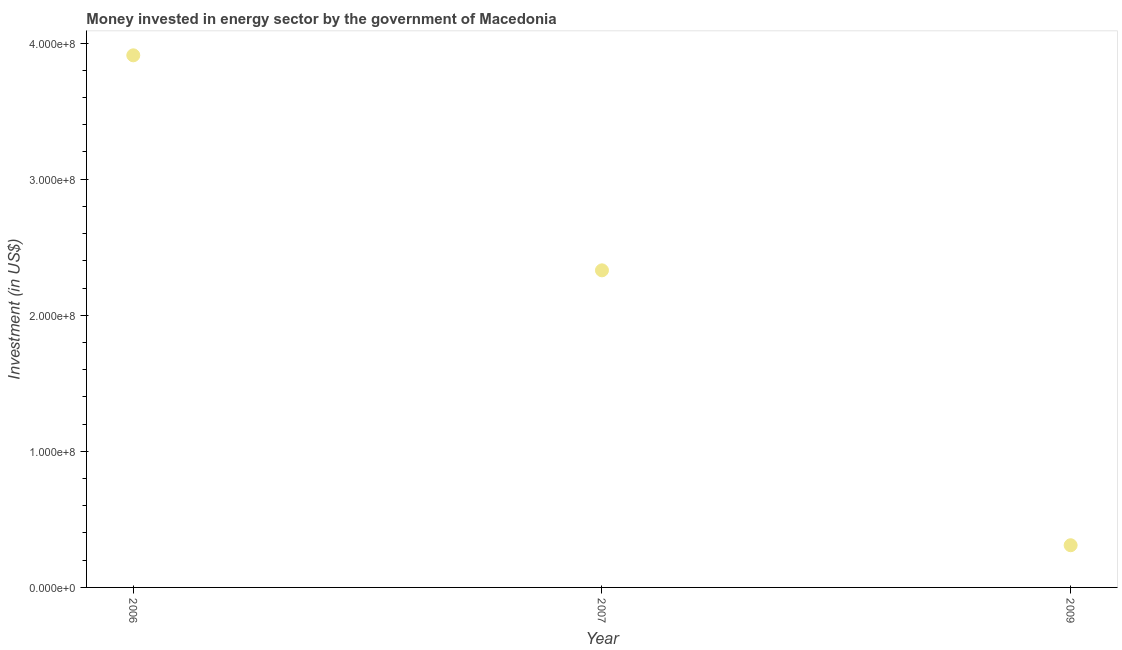What is the investment in energy in 2009?
Give a very brief answer. 3.10e+07. Across all years, what is the maximum investment in energy?
Your response must be concise. 3.91e+08. Across all years, what is the minimum investment in energy?
Provide a succinct answer. 3.10e+07. In which year was the investment in energy maximum?
Your answer should be compact. 2006. In which year was the investment in energy minimum?
Keep it short and to the point. 2009. What is the sum of the investment in energy?
Provide a succinct answer. 6.55e+08. What is the difference between the investment in energy in 2007 and 2009?
Your answer should be very brief. 2.02e+08. What is the average investment in energy per year?
Your answer should be compact. 2.18e+08. What is the median investment in energy?
Provide a succinct answer. 2.33e+08. Do a majority of the years between 2006 and 2007 (inclusive) have investment in energy greater than 140000000 US$?
Make the answer very short. Yes. What is the ratio of the investment in energy in 2006 to that in 2009?
Offer a terse response. 12.61. Is the difference between the investment in energy in 2007 and 2009 greater than the difference between any two years?
Your response must be concise. No. What is the difference between the highest and the second highest investment in energy?
Offer a very short reply. 1.58e+08. What is the difference between the highest and the lowest investment in energy?
Offer a very short reply. 3.60e+08. In how many years, is the investment in energy greater than the average investment in energy taken over all years?
Offer a very short reply. 2. What is the difference between two consecutive major ticks on the Y-axis?
Keep it short and to the point. 1.00e+08. Are the values on the major ticks of Y-axis written in scientific E-notation?
Offer a terse response. Yes. Does the graph contain any zero values?
Your answer should be very brief. No. What is the title of the graph?
Ensure brevity in your answer.  Money invested in energy sector by the government of Macedonia. What is the label or title of the X-axis?
Your answer should be compact. Year. What is the label or title of the Y-axis?
Your answer should be compact. Investment (in US$). What is the Investment (in US$) in 2006?
Your response must be concise. 3.91e+08. What is the Investment (in US$) in 2007?
Keep it short and to the point. 2.33e+08. What is the Investment (in US$) in 2009?
Provide a short and direct response. 3.10e+07. What is the difference between the Investment (in US$) in 2006 and 2007?
Provide a succinct answer. 1.58e+08. What is the difference between the Investment (in US$) in 2006 and 2009?
Provide a succinct answer. 3.60e+08. What is the difference between the Investment (in US$) in 2007 and 2009?
Your answer should be compact. 2.02e+08. What is the ratio of the Investment (in US$) in 2006 to that in 2007?
Ensure brevity in your answer.  1.68. What is the ratio of the Investment (in US$) in 2006 to that in 2009?
Offer a very short reply. 12.61. What is the ratio of the Investment (in US$) in 2007 to that in 2009?
Keep it short and to the point. 7.52. 